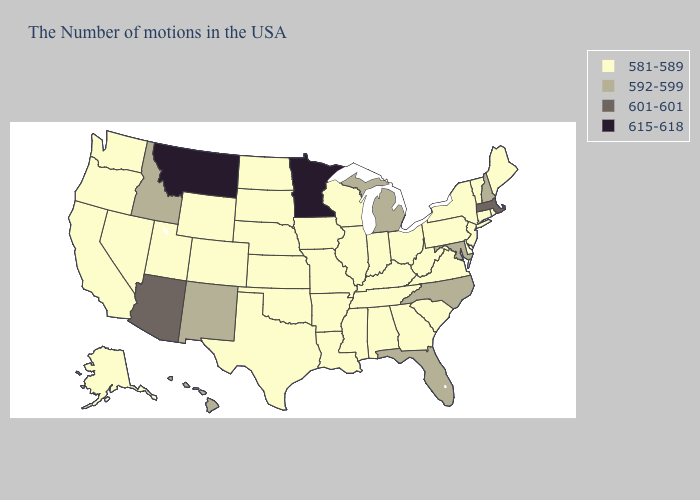Does New Mexico have the lowest value in the West?
Write a very short answer. No. Among the states that border Rhode Island , which have the highest value?
Answer briefly. Massachusetts. Does Kansas have the lowest value in the MidWest?
Short answer required. Yes. Is the legend a continuous bar?
Short answer required. No. What is the value of Michigan?
Answer briefly. 592-599. What is the value of Maine?
Write a very short answer. 581-589. Does Maine have the same value as Idaho?
Short answer required. No. What is the value of North Dakota?
Short answer required. 581-589. What is the highest value in the MidWest ?
Short answer required. 615-618. What is the highest value in the MidWest ?
Short answer required. 615-618. What is the lowest value in the USA?
Keep it brief. 581-589. Among the states that border Tennessee , does Georgia have the lowest value?
Concise answer only. Yes. Does Maryland have the highest value in the South?
Write a very short answer. Yes. What is the value of Alaska?
Concise answer only. 581-589. 